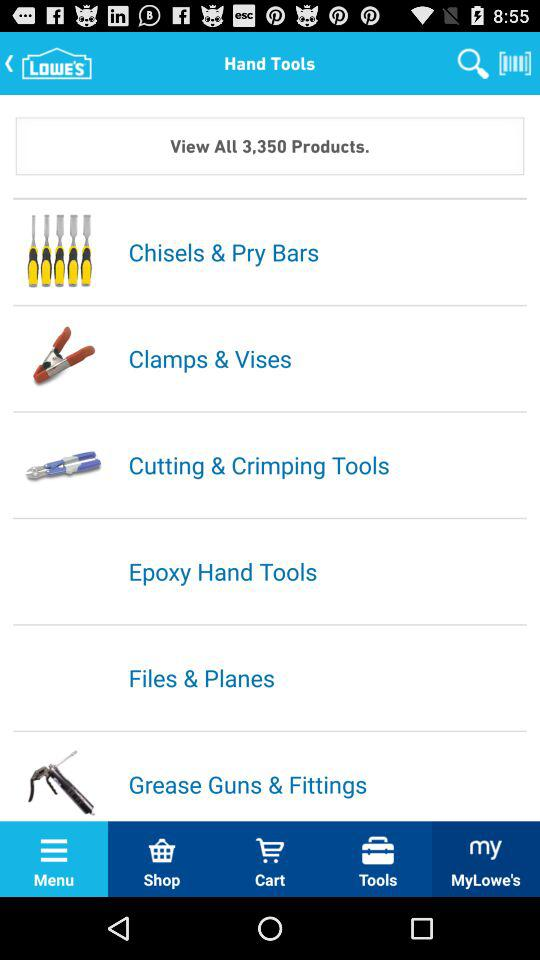How many hand tool categories are there?
Answer the question using a single word or phrase. 6 